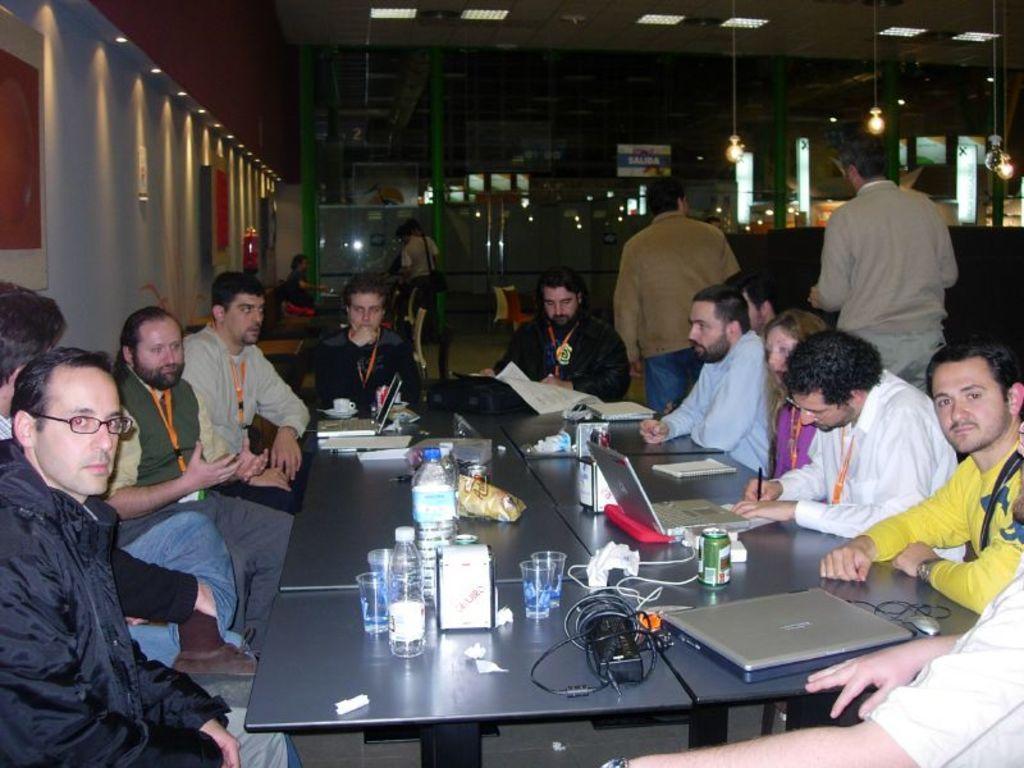In one or two sentences, can you explain what this image depicts? In the center of the image we can see the tables. On the tables we can see the laptops, books, papers, bottles, glasses, tin, wire, mouse, packets, bag, cup and some other objects. Beside the tables we can see some persons are sitting on the chairs. In the background of the image we can see the wall, boards, lights, poles and some persons. At the top of the image we can see the roof and lights. 